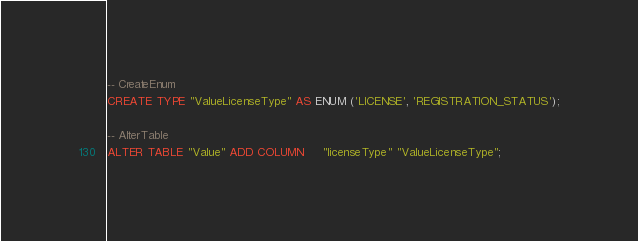Convert code to text. <code><loc_0><loc_0><loc_500><loc_500><_SQL_>-- CreateEnum
CREATE TYPE "ValueLicenseType" AS ENUM ('LICENSE', 'REGISTRATION_STATUS');

-- AlterTable
ALTER TABLE "Value" ADD COLUMN     "licenseType" "ValueLicenseType";
</code> 